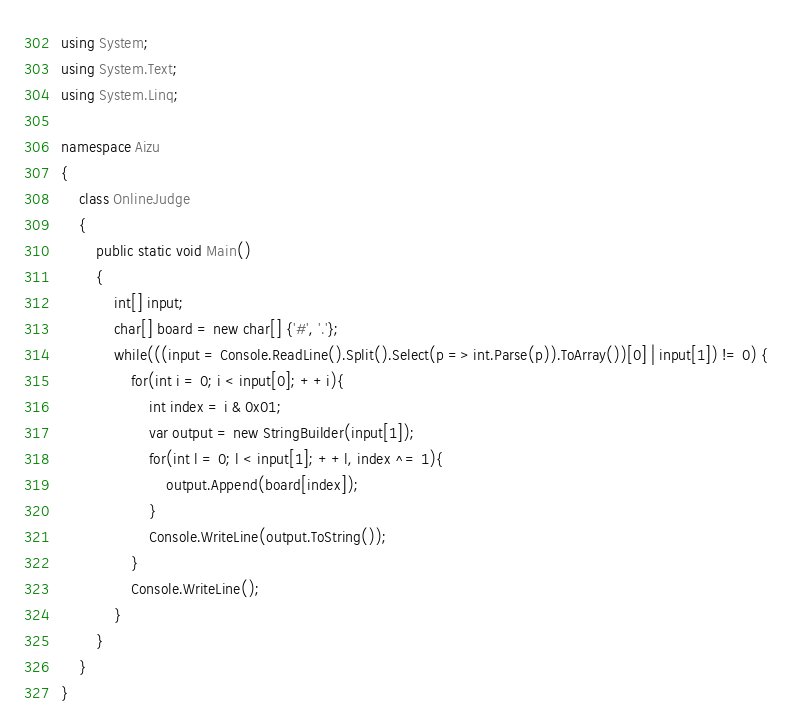Convert code to text. <code><loc_0><loc_0><loc_500><loc_500><_C#_>using System;
using System.Text;
using System.Linq;

namespace Aizu
{
    class OnlineJudge
    {
        public static void Main()
        {
            int[] input;
            char[] board = new char[] {'#', '.'};
            while(((input = Console.ReadLine().Split().Select(p => int.Parse(p)).ToArray())[0] | input[1]) != 0) {
                for(int i = 0; i < input[0]; ++i){
                    int index = i & 0x01;
                    var output = new StringBuilder(input[1]);
                    for(int l = 0; l < input[1]; ++l, index ^= 1){
                        output.Append(board[index]);
                    }
                    Console.WriteLine(output.ToString());
                }
                Console.WriteLine();
            }
        }
    }
}</code> 